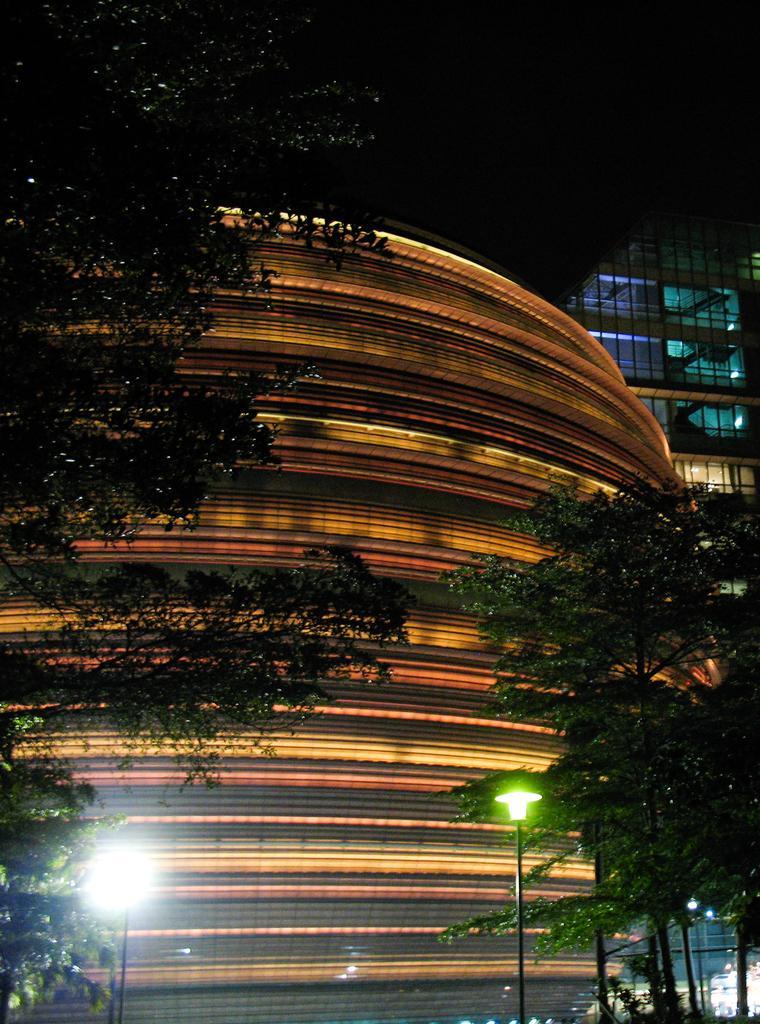In one or two sentences, can you explain what this image depicts? In this image we can see some buildings and at the foreground of the image there are some lights, trees. 